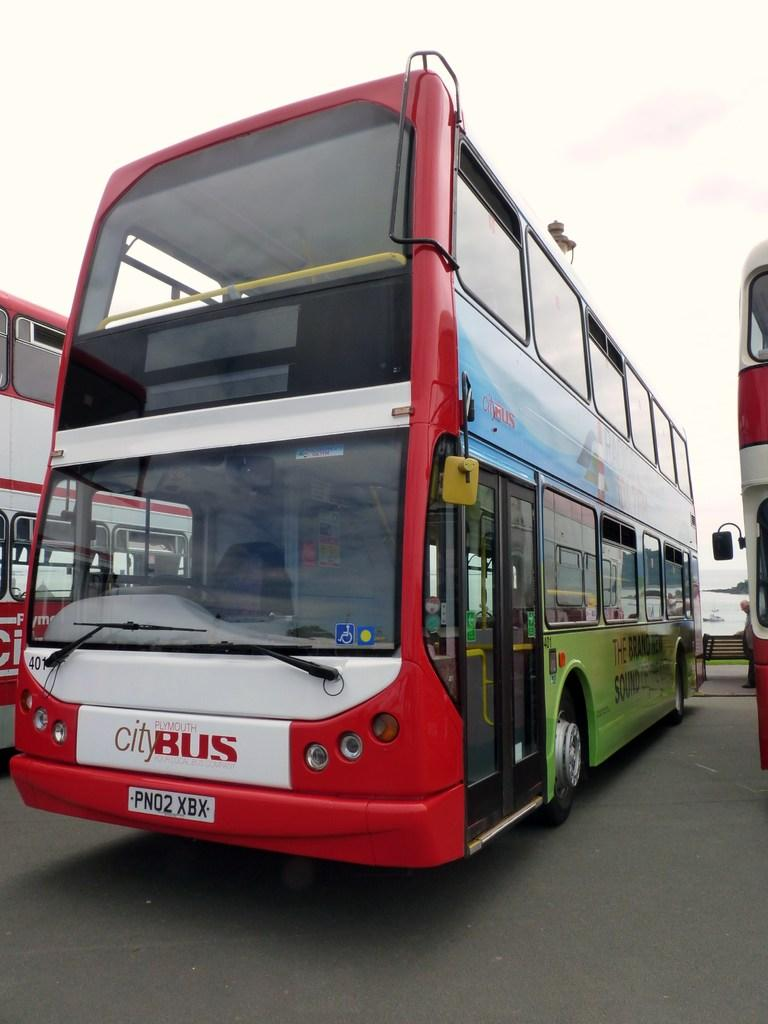How many buses are in the image? There are three buses in the image. Can you describe any other objects or people in the image? There is a person standing behind a bench in the background of the image. What is visible at the top of the image? The sky is visible at the top of the image. What type of knee injury is the person on the bus suffering from in the image? There is no person on the bus mentioned in the image, and no information about any injuries is provided. 